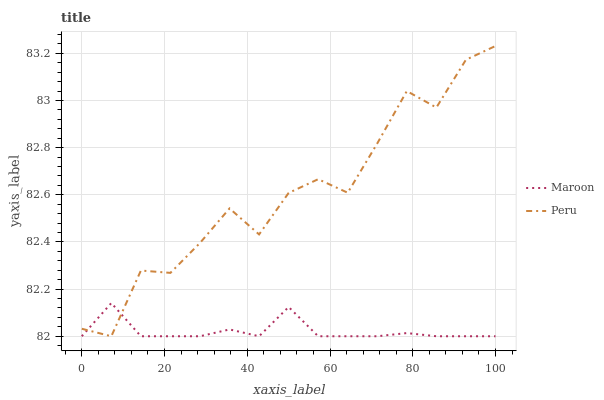Does Maroon have the minimum area under the curve?
Answer yes or no. Yes. Does Peru have the maximum area under the curve?
Answer yes or no. Yes. Does Maroon have the maximum area under the curve?
Answer yes or no. No. Is Maroon the smoothest?
Answer yes or no. Yes. Is Peru the roughest?
Answer yes or no. Yes. Is Maroon the roughest?
Answer yes or no. No. Does Peru have the lowest value?
Answer yes or no. Yes. Does Peru have the highest value?
Answer yes or no. Yes. Does Maroon have the highest value?
Answer yes or no. No. Does Peru intersect Maroon?
Answer yes or no. Yes. Is Peru less than Maroon?
Answer yes or no. No. Is Peru greater than Maroon?
Answer yes or no. No. 